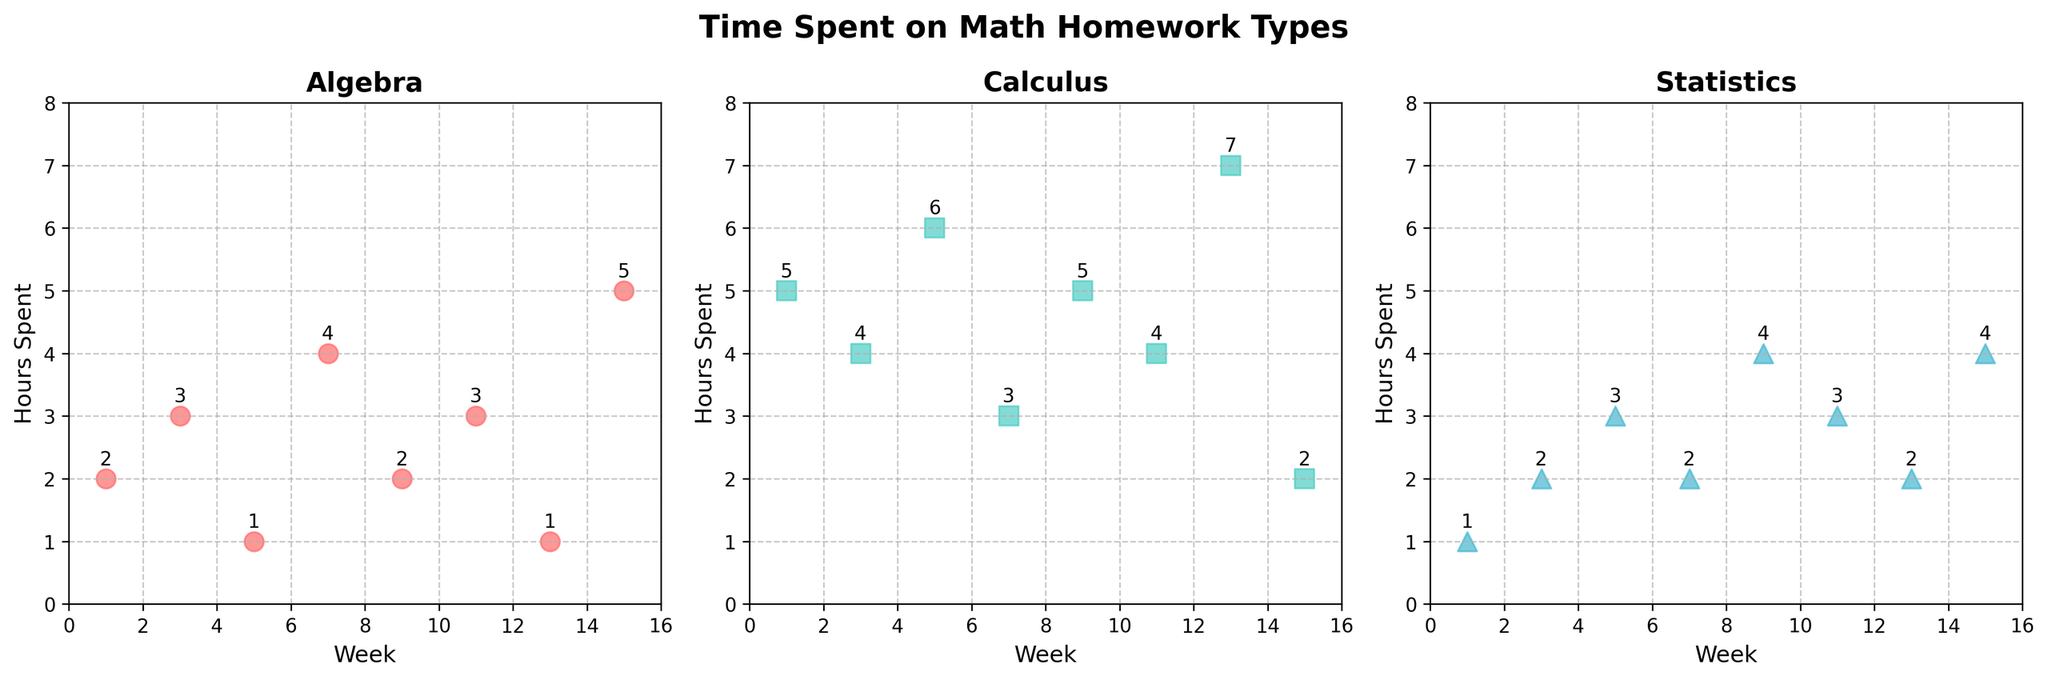How many different math subjects are represented in the plots? The figure has three subplots, each representing one math subject. The titles of the subplots are "Algebra," "Calculus," and "Statistics."
Answer: Three What is the title of the entire figure? The title is located at the top center of the figure, and it reads "Time Spent on Math Homework Types."
Answer: Time Spent on Math Homework Types Which week shows the highest number of hours spent on Algebra? By observing the scatter plot for Algebra, the highest point on the y-axis is at Week 15, with 5 hours.
Answer: Week 15 Between Algebra and Calculus, which subject has a larger range of hours spent over the semester? Calculus ranges from 2 to 7 hours, which spans 5 hours. Algebra ranges from 1 to 5 hours, which spans 4 hours. Therefore, Calculus has a larger range.
Answer: Calculus What is the total number of hours spent on Statistics in Weeks 1, 5, and 9 combined? Summing the hours from the Statistics subplot, Week 1 has 1 hour, Week 5 has 3 hours, and Week 9 has 4 hours. The total is 1 + 3 + 4 = 8 hours.
Answer: 8 On average, how many hours are spent on Calculus per week? Add all hours spent on Calculus: 5 + 4 + 6 + 3 + 5 + 4 + 7 + 2 = 36. There are 8 data points/weeks. Average: 36/8 = 4.5 hours.
Answer: 4.5 Which subject had the least variation in hours spent throughout the semester? For each subject, calculate the range: Algebra (1 to 5 hours = 4 hours), Calculus (2 to 7 hours = 5 hours), and Statistics (1 to 4 hours = 3 hours). Statistics has the least variation.
Answer: Statistics In which week did students spend more hours on Algebra than on Calculus and Statistics? Observing the scatter plots, in Week 7, students spent 4 hours on Algebra, which is more than the hours spent on Calculus (3) and Statistics (2).
Answer: Week 7 Which weeks show equal hours spent on Calculus and Statistics? Check the Calculus and Statistics subplots: Weeks 3 and 11 both show equal hours of 4 for Calculus and 4 and 3 for Statistics, respectively. Hence, Week 11 shows equal hours (both are 3).
Answer: Week 11 